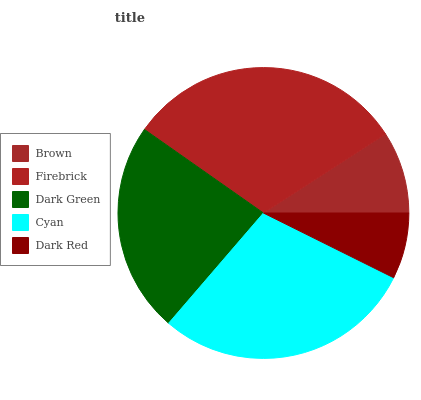Is Dark Red the minimum?
Answer yes or no. Yes. Is Firebrick the maximum?
Answer yes or no. Yes. Is Dark Green the minimum?
Answer yes or no. No. Is Dark Green the maximum?
Answer yes or no. No. Is Firebrick greater than Dark Green?
Answer yes or no. Yes. Is Dark Green less than Firebrick?
Answer yes or no. Yes. Is Dark Green greater than Firebrick?
Answer yes or no. No. Is Firebrick less than Dark Green?
Answer yes or no. No. Is Dark Green the high median?
Answer yes or no. Yes. Is Dark Green the low median?
Answer yes or no. Yes. Is Brown the high median?
Answer yes or no. No. Is Firebrick the low median?
Answer yes or no. No. 